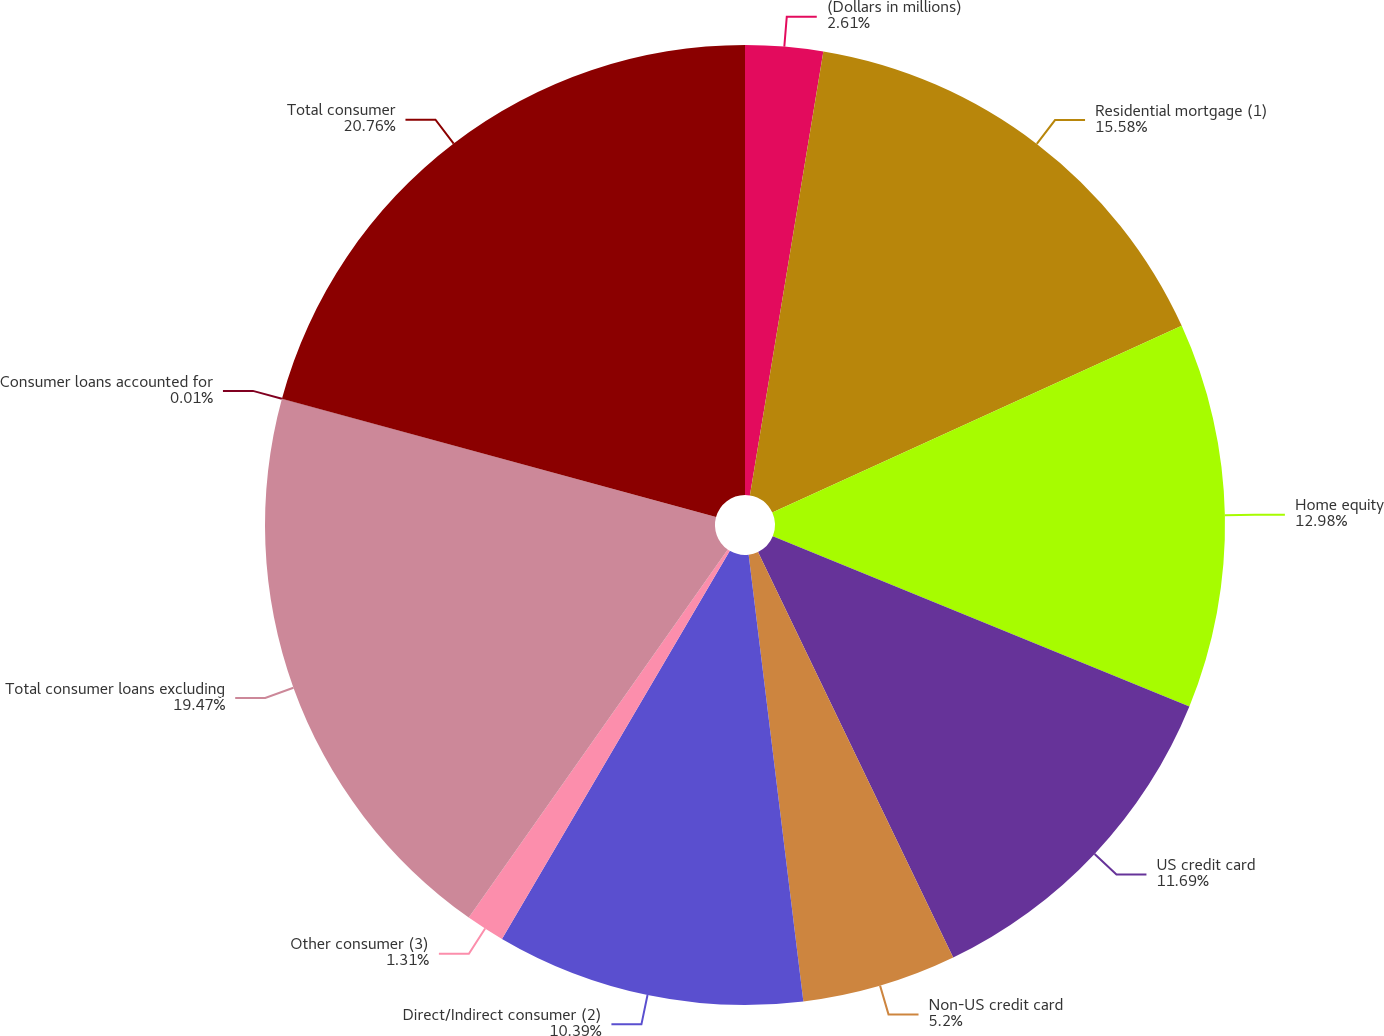Convert chart. <chart><loc_0><loc_0><loc_500><loc_500><pie_chart><fcel>(Dollars in millions)<fcel>Residential mortgage (1)<fcel>Home equity<fcel>US credit card<fcel>Non-US credit card<fcel>Direct/Indirect consumer (2)<fcel>Other consumer (3)<fcel>Total consumer loans excluding<fcel>Consumer loans accounted for<fcel>Total consumer<nl><fcel>2.61%<fcel>15.58%<fcel>12.98%<fcel>11.69%<fcel>5.2%<fcel>10.39%<fcel>1.31%<fcel>19.47%<fcel>0.01%<fcel>20.76%<nl></chart> 